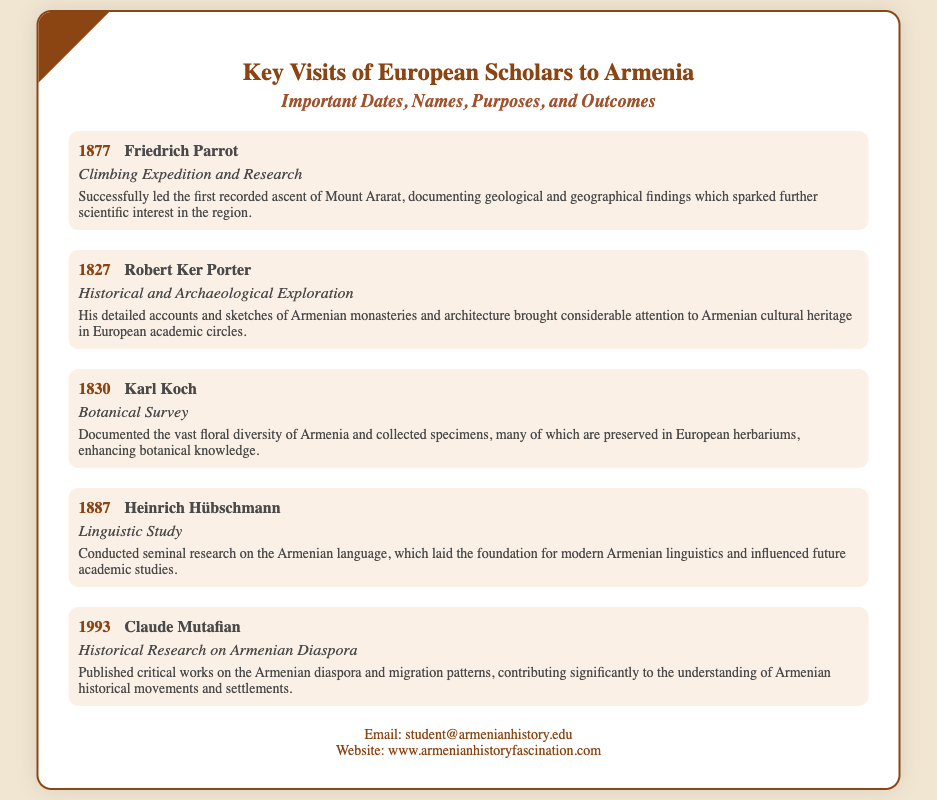What year did Friedrich Parrot visit Armenia? The year of Friedrich Parrot's visit is explicitly mentioned in the document.
Answer: 1877 What was the purpose of Claude Mutafian's visit? The document provides specific purposes for each scholar's visits, including that of Claude Mutafian.
Answer: Historical Research on Armenian Diaspora Which scholar is associated with the first recorded ascent of Mount Ararat? The document identifies Friedrich Parrot with a notable achievement during his visit.
Answer: Friedrich Parrot How many scholars are mentioned in the document? The total number of scholars listed in the document can be counted.
Answer: Five What outcome is linked to Heinrich Hübschmann's visit? The outcomes of each scholar's visit are summarized in the document, including Hübschmann's contributions.
Answer: Laid the foundation for modern Armenian linguistics Which scholar conducted a botanical survey in 1830? The document explicitly states the year and the respective scholar who conducted the botanical survey.
Answer: Karl Koch 